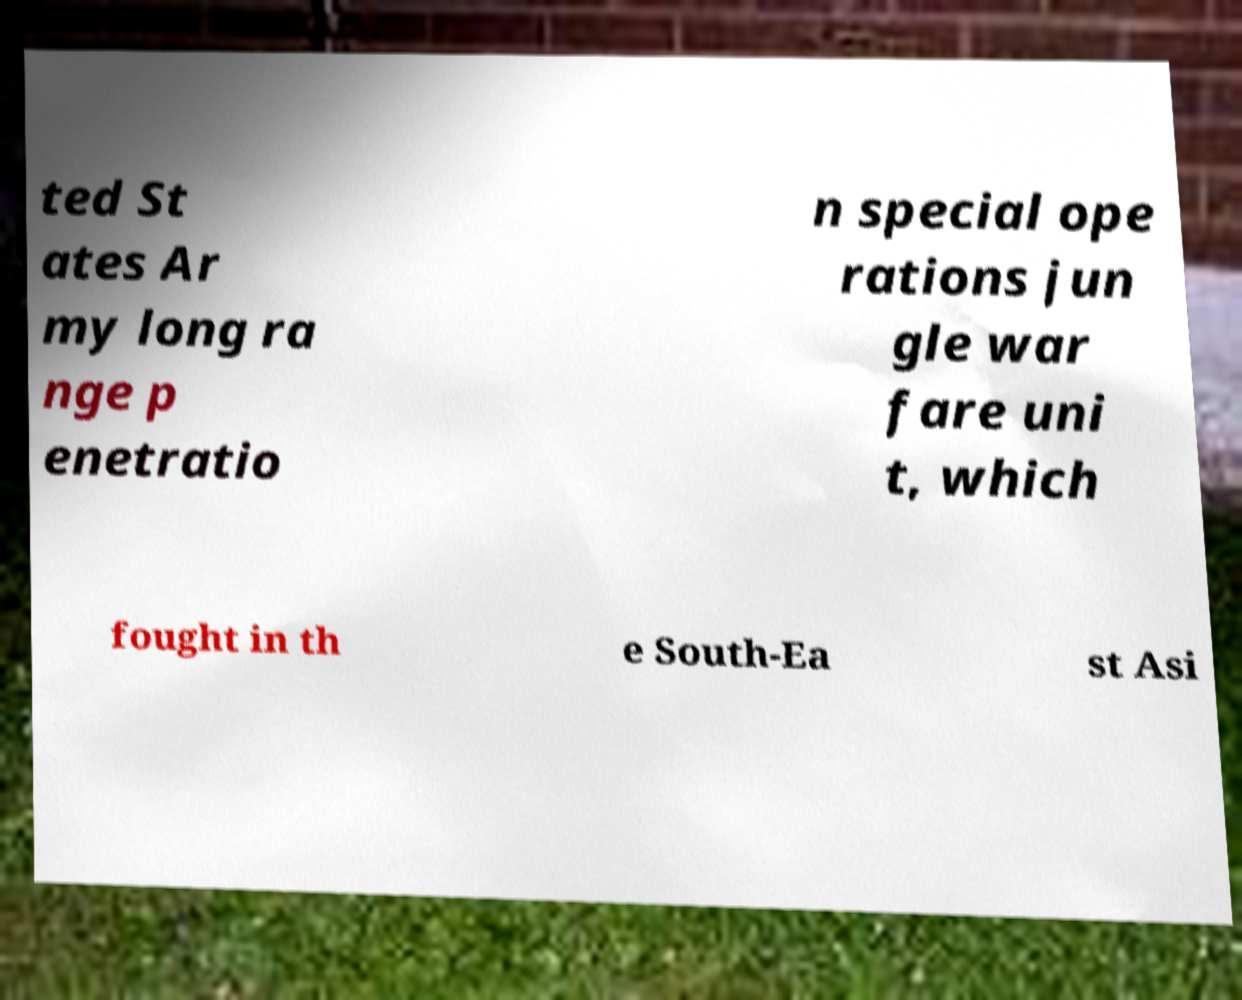Could you assist in decoding the text presented in this image and type it out clearly? ted St ates Ar my long ra nge p enetratio n special ope rations jun gle war fare uni t, which fought in th e South-Ea st Asi 